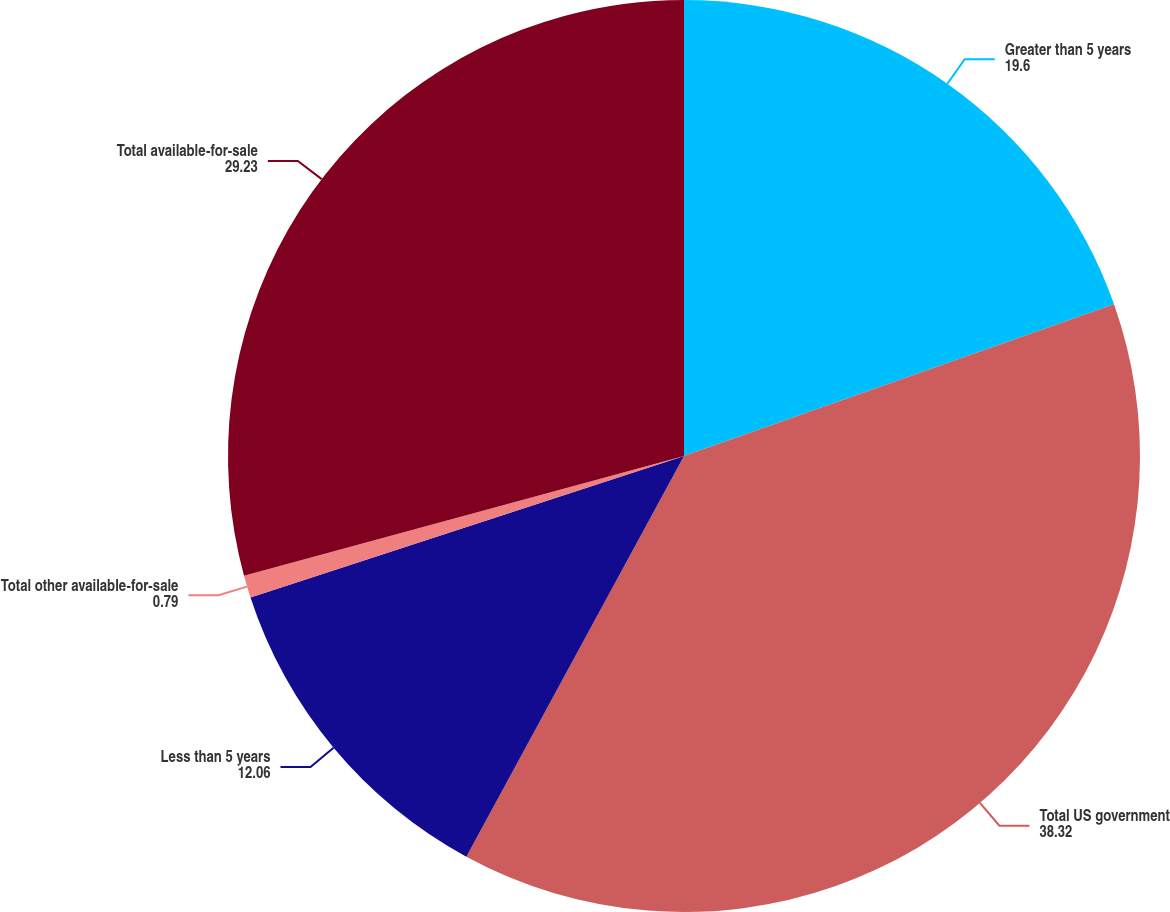<chart> <loc_0><loc_0><loc_500><loc_500><pie_chart><fcel>Greater than 5 years<fcel>Total US government<fcel>Less than 5 years<fcel>Total other available-for-sale<fcel>Total available-for-sale<nl><fcel>19.6%<fcel>38.32%<fcel>12.06%<fcel>0.79%<fcel>29.23%<nl></chart> 